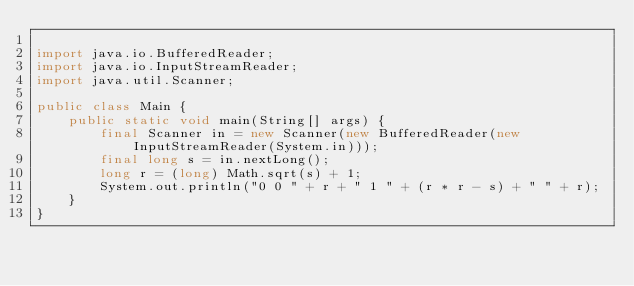<code> <loc_0><loc_0><loc_500><loc_500><_Java_>
import java.io.BufferedReader;
import java.io.InputStreamReader;
import java.util.Scanner;

public class Main {
    public static void main(String[] args) {
        final Scanner in = new Scanner(new BufferedReader(new InputStreamReader(System.in)));
        final long s = in.nextLong();
        long r = (long) Math.sqrt(s) + 1;
        System.out.println("0 0 " + r + " 1 " + (r * r - s) + " " + r);
    }
}
</code> 